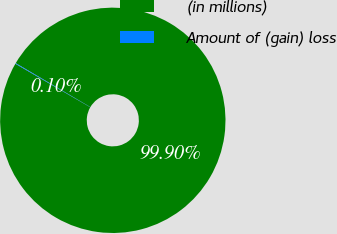<chart> <loc_0><loc_0><loc_500><loc_500><pie_chart><fcel>(in millions)<fcel>Amount of (gain) loss<nl><fcel>99.9%<fcel>0.1%<nl></chart> 